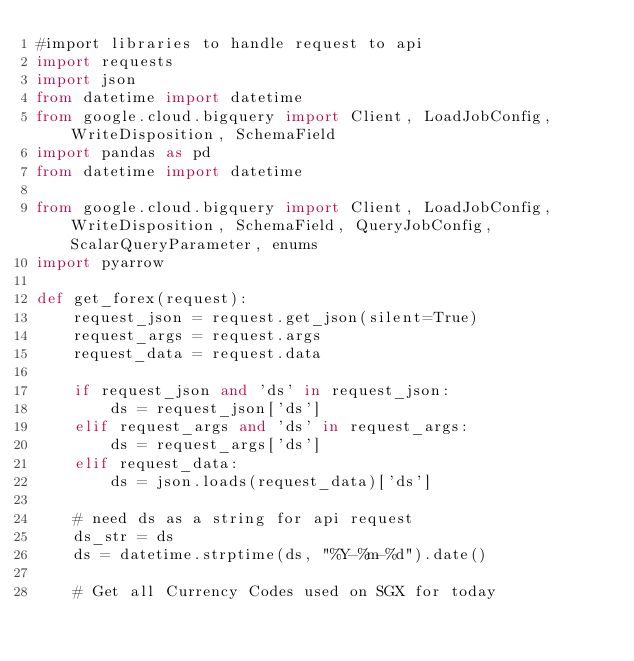Convert code to text. <code><loc_0><loc_0><loc_500><loc_500><_Python_>#import libraries to handle request to api
import requests
import json
from datetime import datetime
from google.cloud.bigquery import Client, LoadJobConfig, WriteDisposition, SchemaField
import pandas as pd
from datetime import datetime

from google.cloud.bigquery import Client, LoadJobConfig, WriteDisposition, SchemaField, QueryJobConfig, ScalarQueryParameter, enums
import pyarrow

def get_forex(request):
    request_json = request.get_json(silent=True)
    request_args = request.args
    request_data = request.data

    if request_json and 'ds' in request_json:
        ds = request_json['ds']
    elif request_args and 'ds' in request_args:
        ds = request_args['ds']
    elif request_data:
        ds = json.loads(request_data)['ds']

    # need ds as a string for api request
    ds_str = ds
    ds = datetime.strptime(ds, "%Y-%m-%d").date()

    # Get all Currency Codes used on SGX for today</code> 